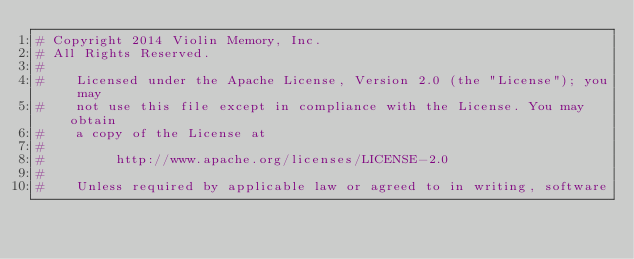<code> <loc_0><loc_0><loc_500><loc_500><_Python_># Copyright 2014 Violin Memory, Inc.
# All Rights Reserved.
#
#    Licensed under the Apache License, Version 2.0 (the "License"); you may
#    not use this file except in compliance with the License. You may obtain
#    a copy of the License at
#
#         http://www.apache.org/licenses/LICENSE-2.0
#
#    Unless required by applicable law or agreed to in writing, software</code> 